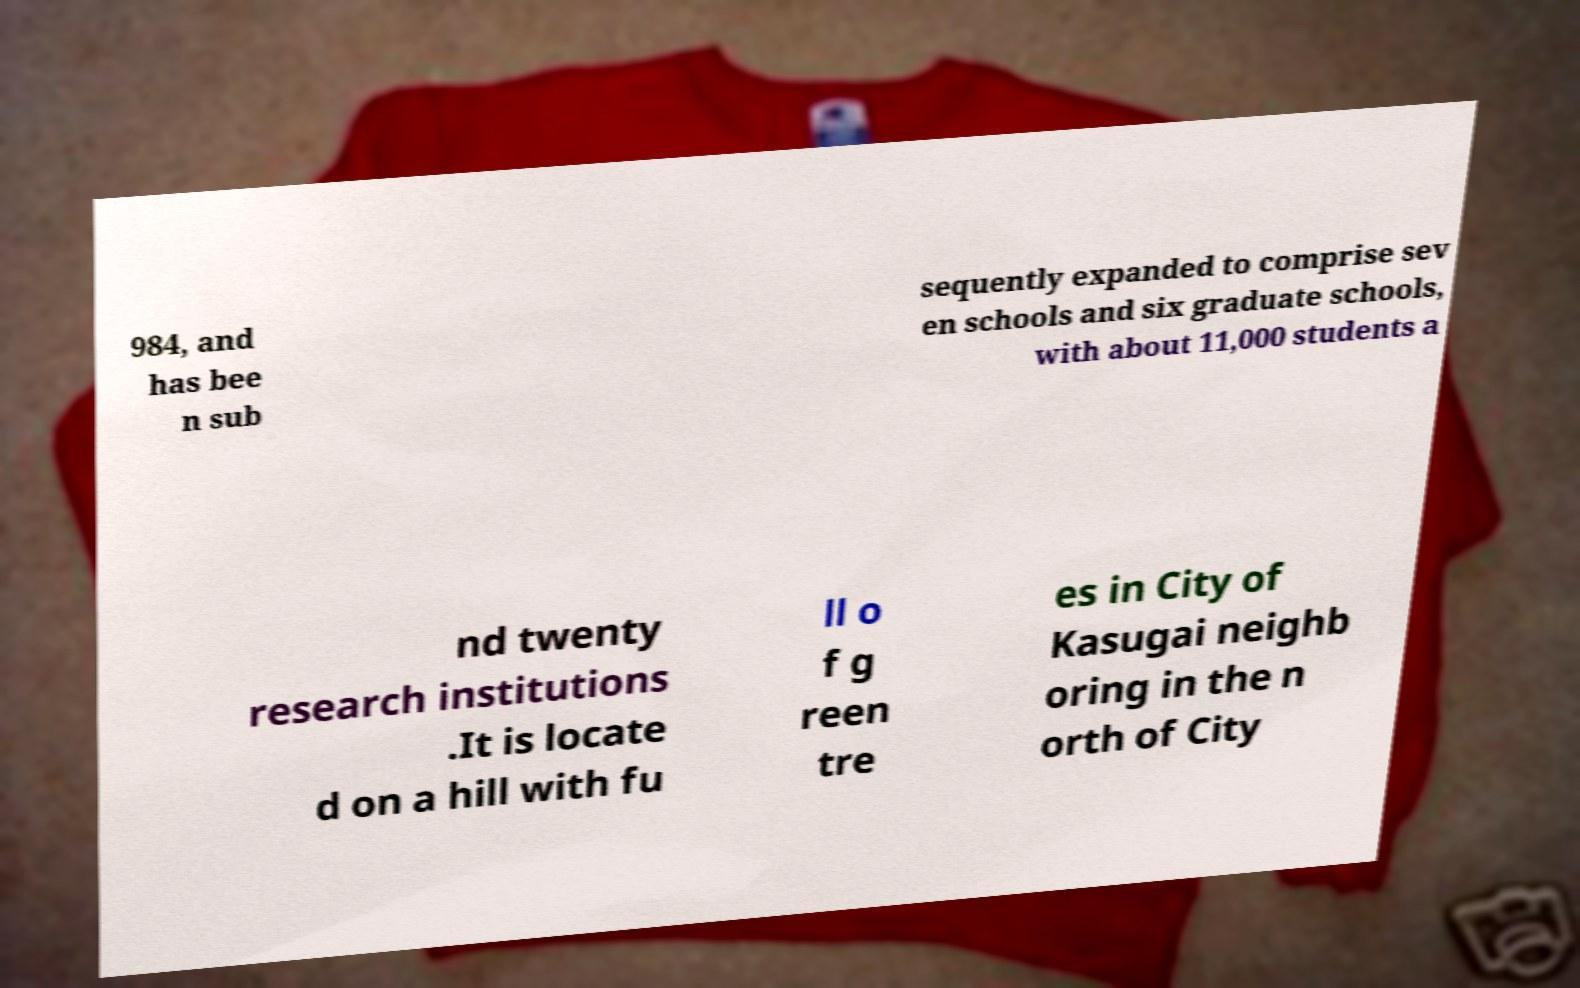I need the written content from this picture converted into text. Can you do that? 984, and has bee n sub sequently expanded to comprise sev en schools and six graduate schools, with about 11,000 students a nd twenty research institutions .It is locate d on a hill with fu ll o f g reen tre es in City of Kasugai neighb oring in the n orth of City 